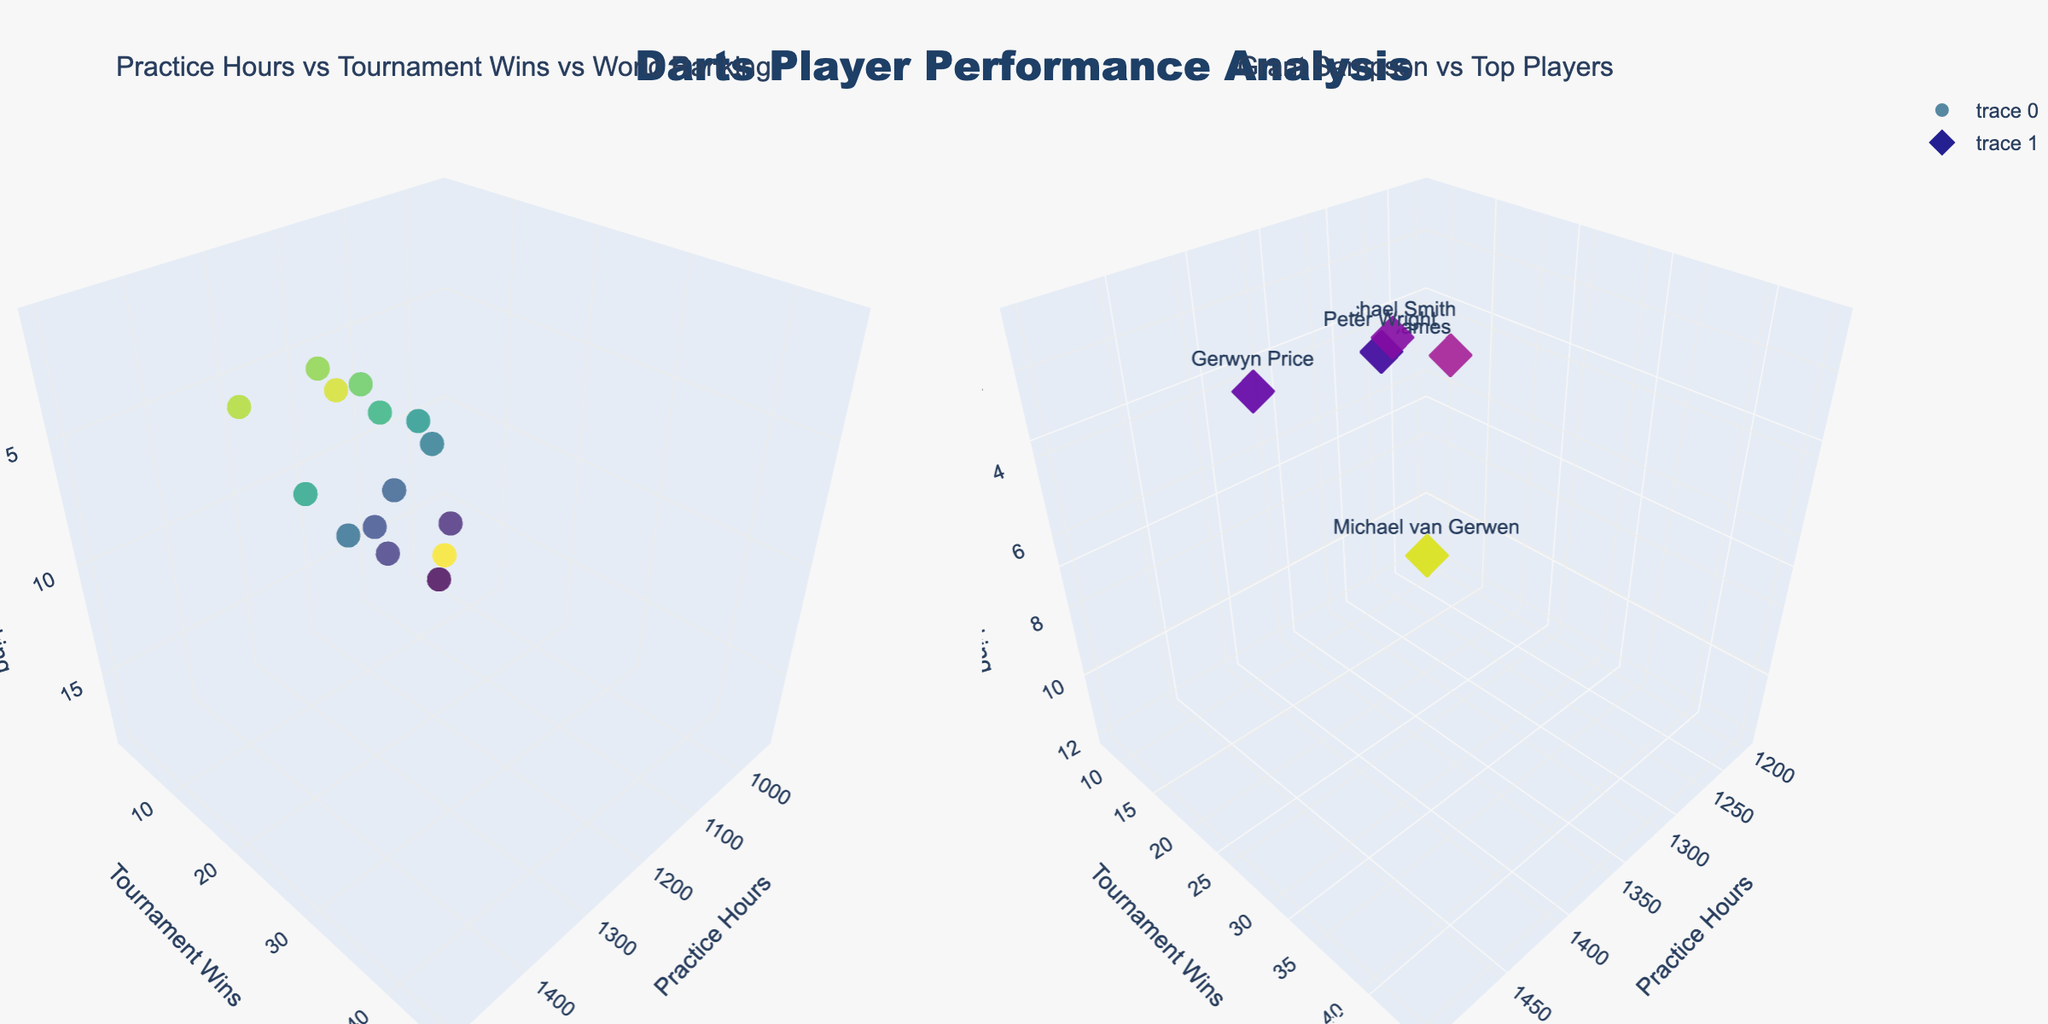What is the title of the figure? The title of the figure is displayed at the top center of the figure. It reads "Darts Player Performance Analysis."
Answer: Darts Player Performance Analysis How many subplots are there in the figure? There are two distinct subplots in the figure, with titles "Practice Hours vs Tournament Wins vs World Ranking" and "Grant Sampson vs Top Players."
Answer: Two Which player has the highest world ranking in the second subplot? The second subplot compares Grant Sampson against the top 5 players by their world ranking. Michael van Gerwen, with a world ranking of 1, is the highest-ranked player.
Answer: Michael van Gerwen How many tournament wins does Grant Sampson have according to the first subplot? By hovering over the marker representing Grant Sampson in the first subplot, we can see that he has 8 tournament wins.
Answer: 8 What is the color scale used for world rankings in the first subplot? The first subplot uses a "Viridis" color scale which changes colors depending on the value of the world rankings, making higher-ranked players stand out with different colors.
Answer: Viridis Are there any players in the second subplot with fewer practice hours but higher rankings than Grant Sampson? Comparing the practice hours and world rankings in the second subplot, all top 5 players have higher world rankings. Specifically, Michael Smith has fewer practice hours at 1250 but a higher world ranking at 4.
Answer: Michael Smith What relationship between practice hours and tournament wins can be observed in the first subplot? There is a general trend in the first subplot indicating that players with more practice hours tend to have more tournament wins, although this is not a strict rule as some players deviate from this trend.
Answer: More practice hours generally result in more tournament wins Compare the practice hours of Peter Wright and Grant Sampson. By examining the plot, Peter Wright has 1350 practice hours while Grant Sampson has 1200 practice hours. Therefore, Peter Wright practices more hours than Grant Sampson.
Answer: Peter Wright practices 150 hours more Which player(s) have the same number of practice hours as Grant Sampson, and what are their world rankings? In the first subplot, James Wade has the same number of practice hours as Grant Sampson, which is 1200. However, his world ranking is 5, higher than Grant Sampson's ranking of 12.
Answer: James Wade What is the correlation between world ranking and tournament wins in the second subplot? In the second subplot, players with better world rankings (lower numbers) generally have more tournament wins. Grant Sampson stands out with fewer wins compared to these top players.
Answer: Better ranking, more wins 